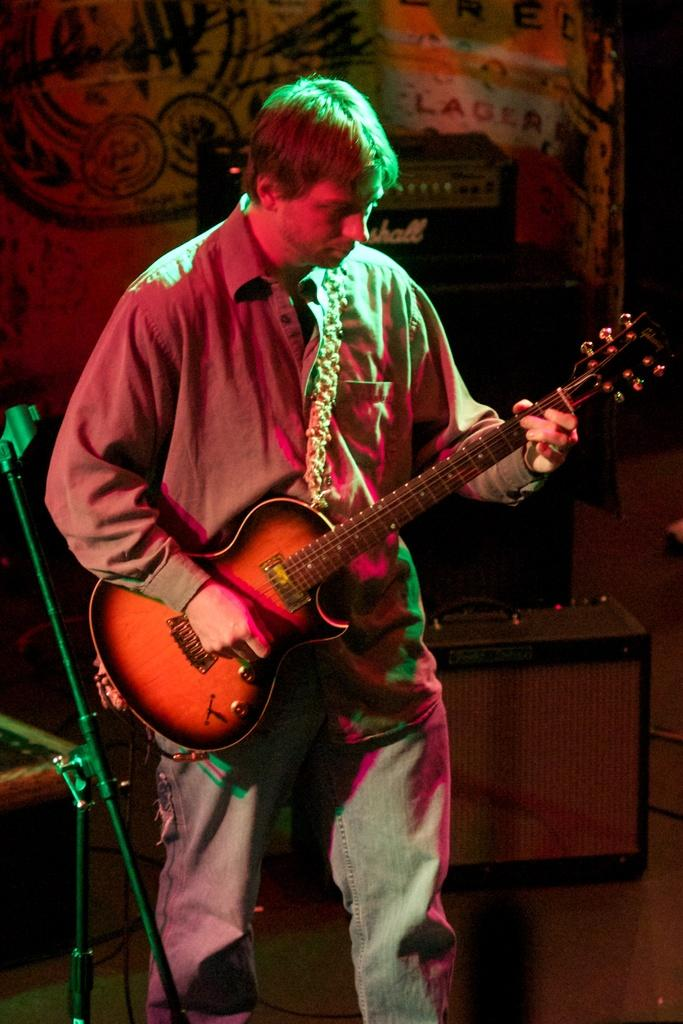Who is present in the image? There is a man in the image. What is the man doing in the image? The man is standing in the image. What is the man holding in his hands? The man is holding a guitar in his hands. Is there any equipment related to the guitar in the image? Yes, there is a guitar stand in the image. How many family members are visible in the image? There is no family member visible in the image, only the man holding a guitar. Can you see a yak in the image? No, there is no yak present in the image. 